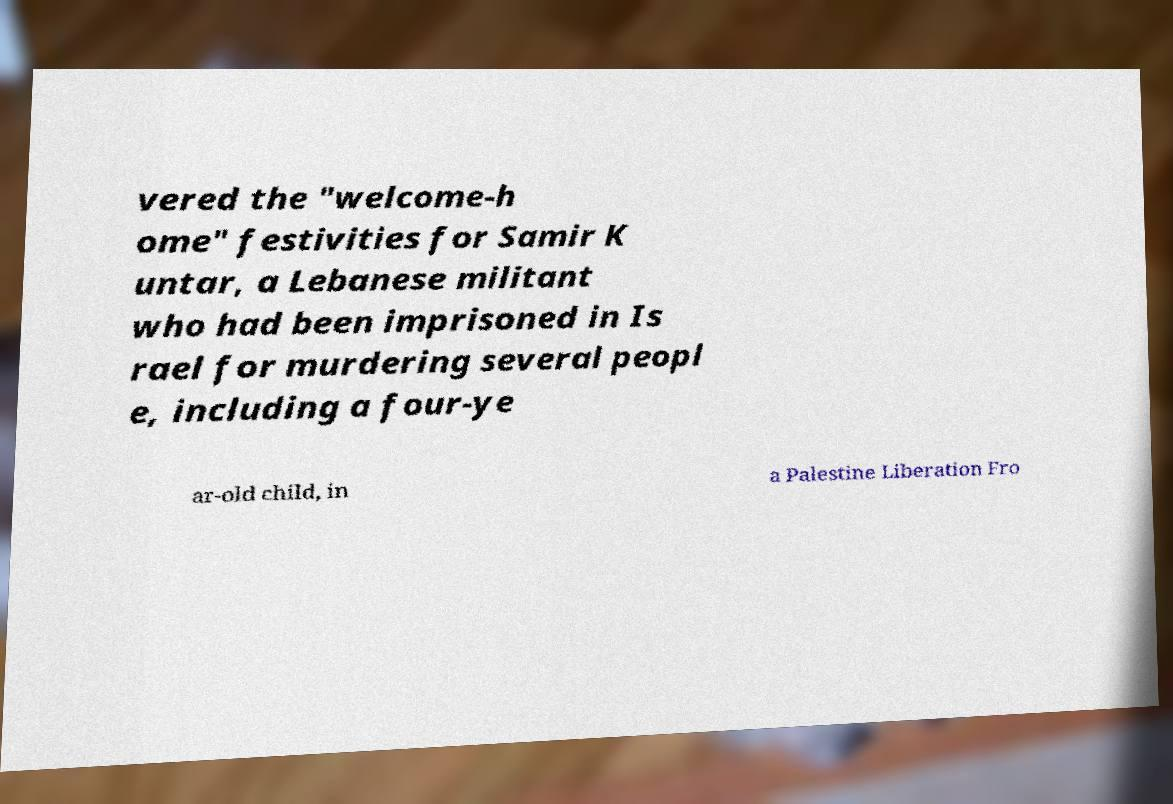Could you assist in decoding the text presented in this image and type it out clearly? vered the "welcome-h ome" festivities for Samir K untar, a Lebanese militant who had been imprisoned in Is rael for murdering several peopl e, including a four-ye ar-old child, in a Palestine Liberation Fro 